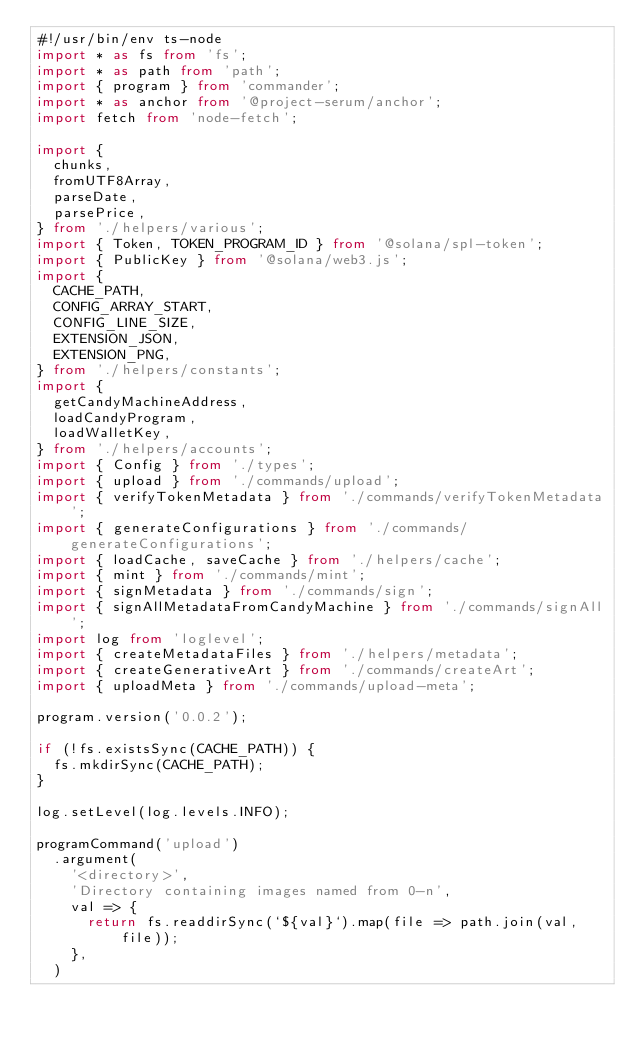Convert code to text. <code><loc_0><loc_0><loc_500><loc_500><_TypeScript_>#!/usr/bin/env ts-node
import * as fs from 'fs';
import * as path from 'path';
import { program } from 'commander';
import * as anchor from '@project-serum/anchor';
import fetch from 'node-fetch';

import {
  chunks,
  fromUTF8Array,
  parseDate,
  parsePrice,
} from './helpers/various';
import { Token, TOKEN_PROGRAM_ID } from '@solana/spl-token';
import { PublicKey } from '@solana/web3.js';
import {
  CACHE_PATH,
  CONFIG_ARRAY_START,
  CONFIG_LINE_SIZE,
  EXTENSION_JSON,
  EXTENSION_PNG,
} from './helpers/constants';
import {
  getCandyMachineAddress,
  loadCandyProgram,
  loadWalletKey,
} from './helpers/accounts';
import { Config } from './types';
import { upload } from './commands/upload';
import { verifyTokenMetadata } from './commands/verifyTokenMetadata';
import { generateConfigurations } from './commands/generateConfigurations';
import { loadCache, saveCache } from './helpers/cache';
import { mint } from './commands/mint';
import { signMetadata } from './commands/sign';
import { signAllMetadataFromCandyMachine } from './commands/signAll';
import log from 'loglevel';
import { createMetadataFiles } from './helpers/metadata';
import { createGenerativeArt } from './commands/createArt';
import { uploadMeta } from './commands/upload-meta';

program.version('0.0.2');

if (!fs.existsSync(CACHE_PATH)) {
  fs.mkdirSync(CACHE_PATH);
}

log.setLevel(log.levels.INFO);

programCommand('upload')
  .argument(
    '<directory>',
    'Directory containing images named from 0-n',
    val => {
      return fs.readdirSync(`${val}`).map(file => path.join(val, file));
    },
  )</code> 